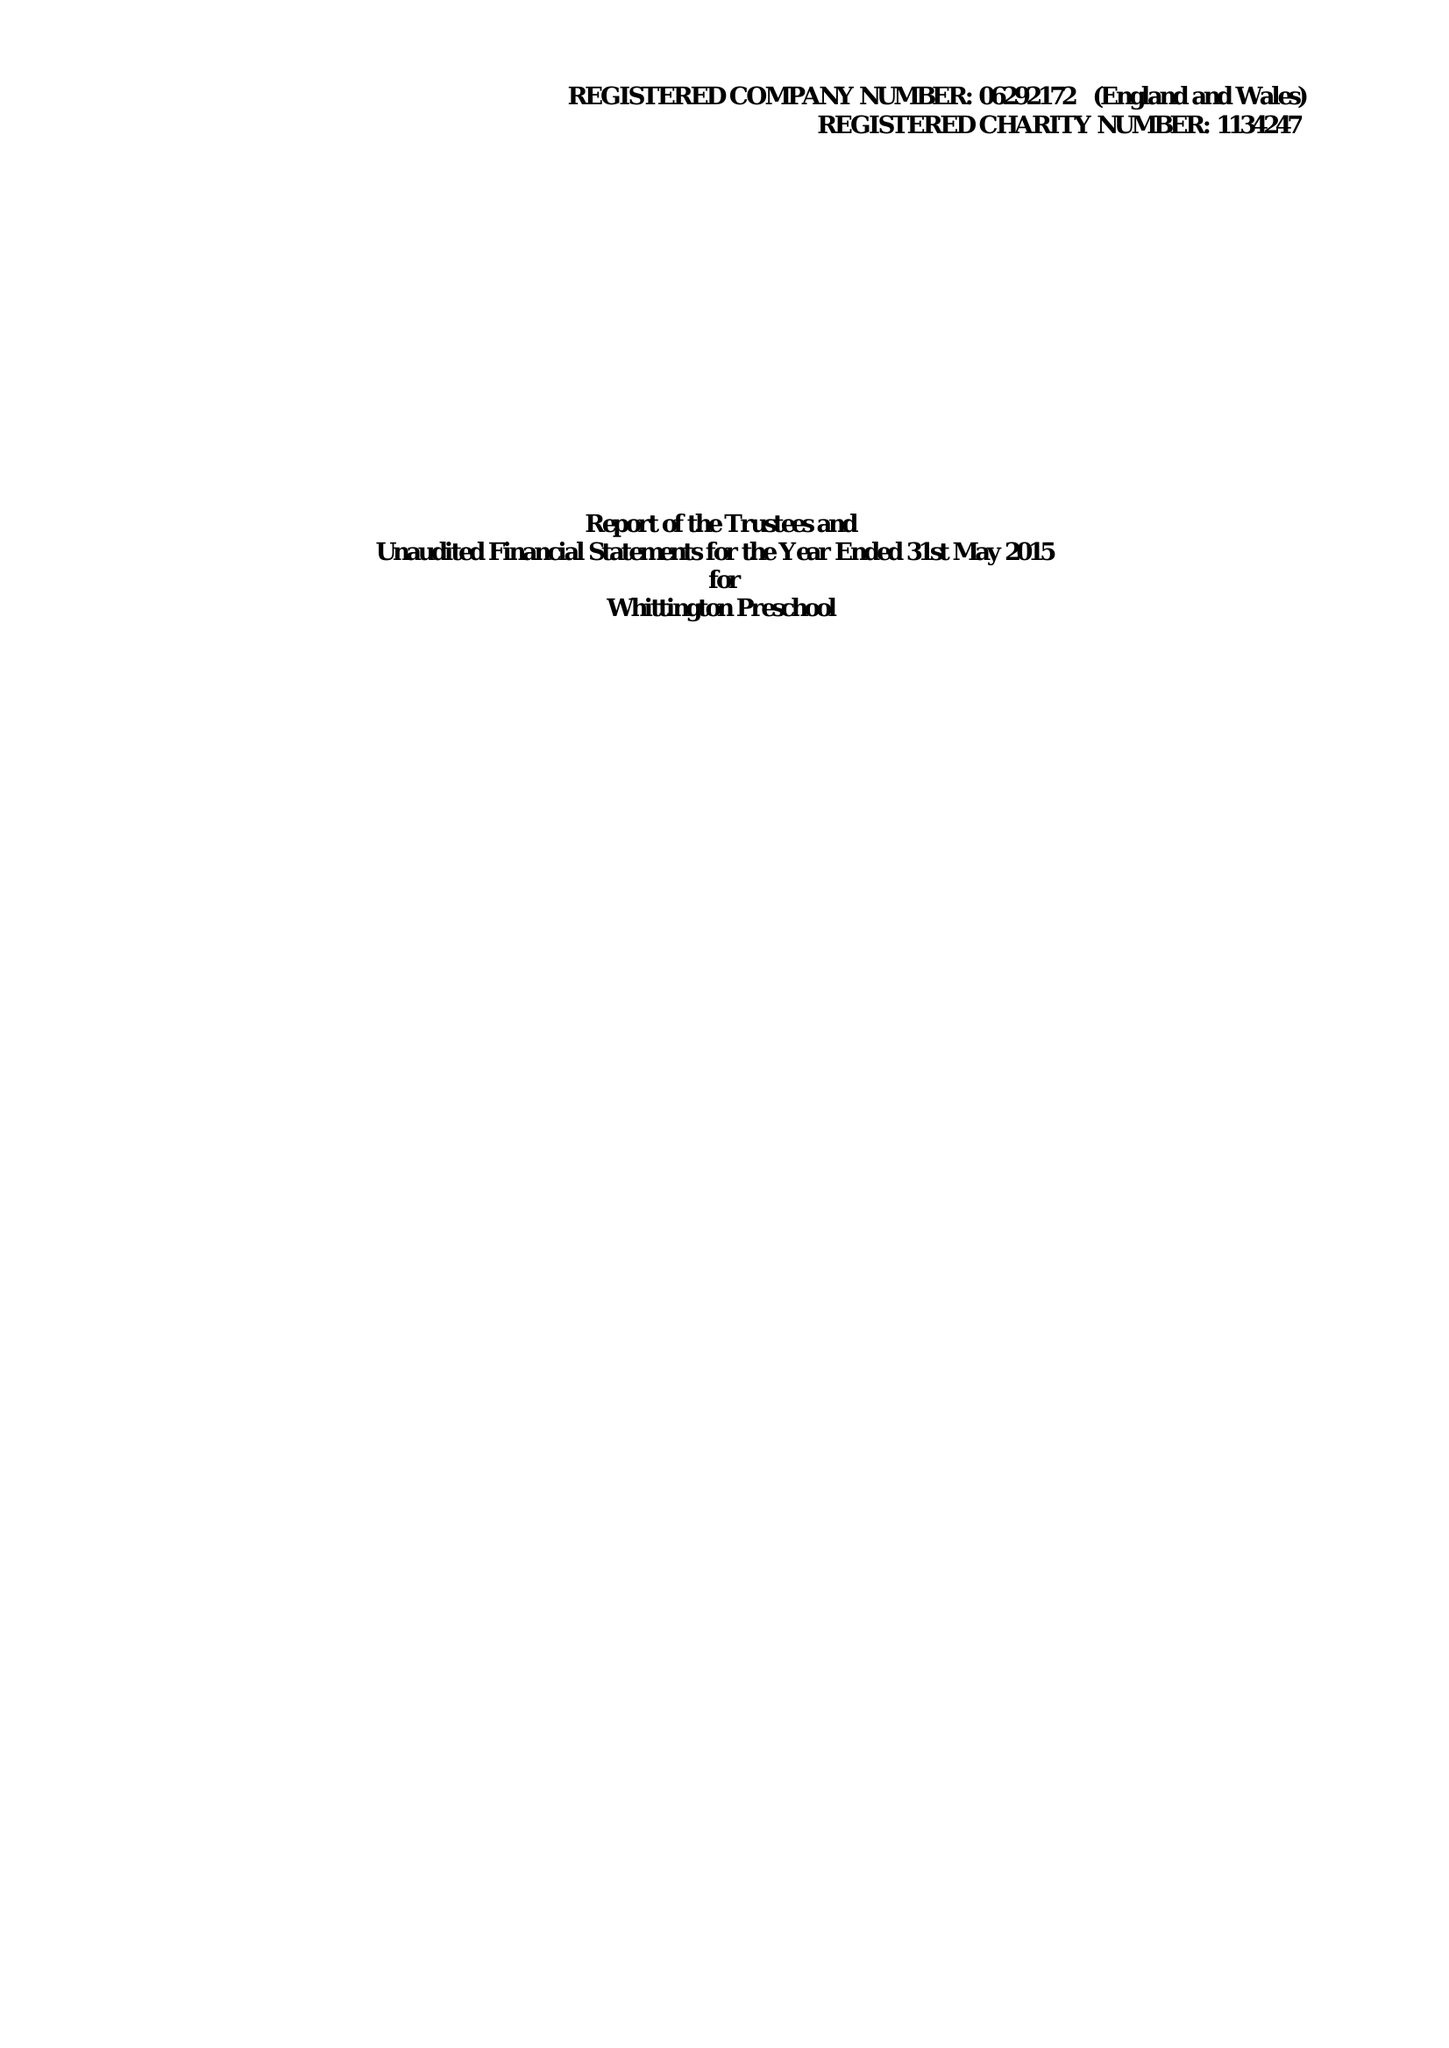What is the value for the spending_annually_in_british_pounds?
Answer the question using a single word or phrase. 211753.00 